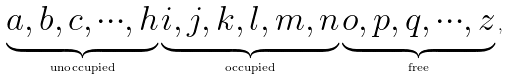<formula> <loc_0><loc_0><loc_500><loc_500>\underbrace { a , b , c , \cdots , h } _ { \text {unoccupied} } \underbrace { i , j , k , l , m , n } _ { \text {occupied} } \underbrace { o , p , q , \cdots , z } _ { \text {free} } \, ,</formula> 